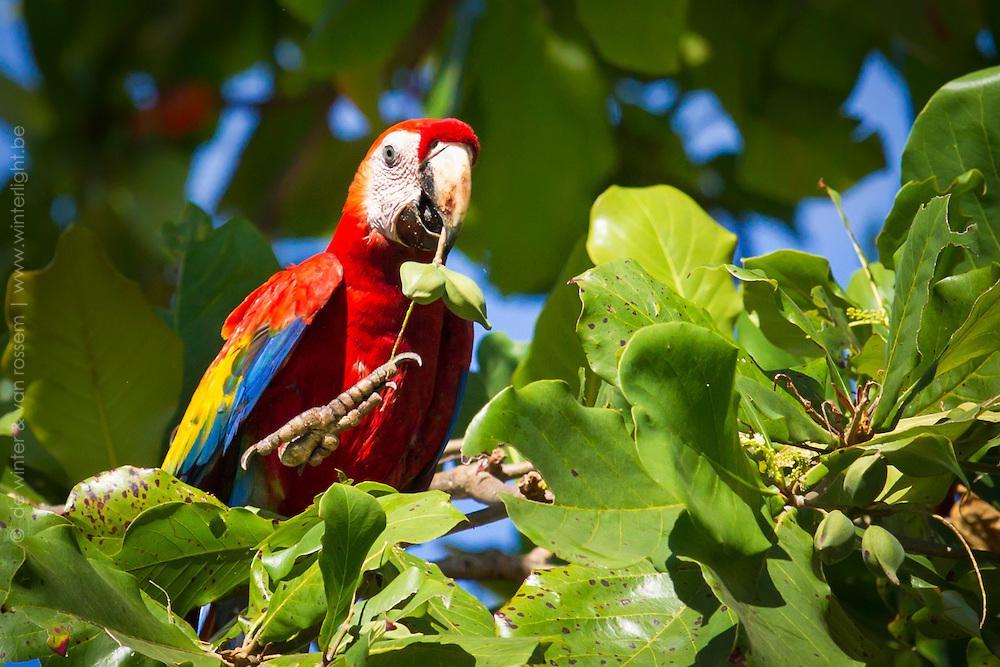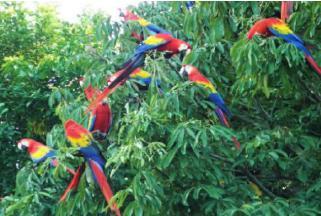The first image is the image on the left, the second image is the image on the right. Analyze the images presented: Is the assertion "All of the birds in the images are sitting in the branches of trees." valid? Answer yes or no. Yes. The first image is the image on the left, the second image is the image on the right. Evaluate the accuracy of this statement regarding the images: "There are no more than three birds in the pair of images.". Is it true? Answer yes or no. No. 